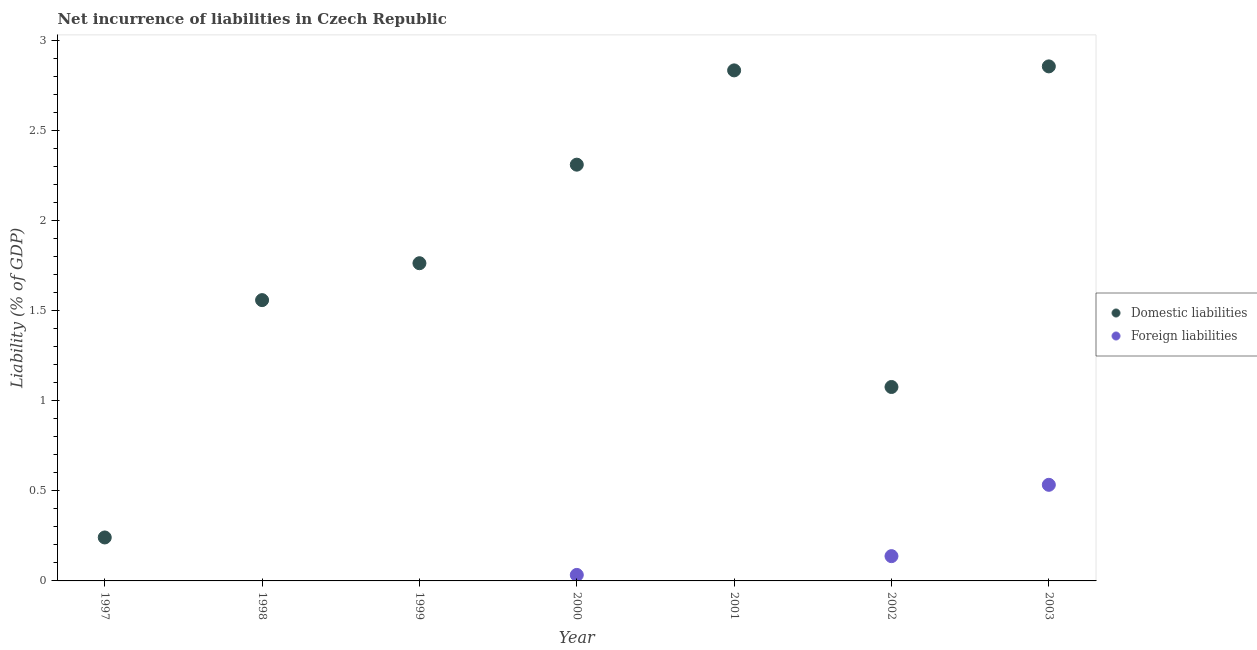Is the number of dotlines equal to the number of legend labels?
Offer a terse response. No. What is the incurrence of domestic liabilities in 1997?
Offer a terse response. 0.24. Across all years, what is the maximum incurrence of domestic liabilities?
Your answer should be compact. 2.86. In which year was the incurrence of foreign liabilities maximum?
Your answer should be compact. 2003. What is the total incurrence of domestic liabilities in the graph?
Ensure brevity in your answer.  12.65. What is the difference between the incurrence of foreign liabilities in 2002 and that in 2003?
Provide a short and direct response. -0.4. What is the difference between the incurrence of domestic liabilities in 2003 and the incurrence of foreign liabilities in 1999?
Keep it short and to the point. 2.86. What is the average incurrence of foreign liabilities per year?
Keep it short and to the point. 0.1. In the year 2002, what is the difference between the incurrence of foreign liabilities and incurrence of domestic liabilities?
Ensure brevity in your answer.  -0.94. In how many years, is the incurrence of domestic liabilities greater than 2.2 %?
Give a very brief answer. 3. What is the ratio of the incurrence of domestic liabilities in 1999 to that in 2000?
Your answer should be very brief. 0.76. Is the incurrence of domestic liabilities in 1998 less than that in 2003?
Your answer should be very brief. Yes. Is the difference between the incurrence of domestic liabilities in 2000 and 2002 greater than the difference between the incurrence of foreign liabilities in 2000 and 2002?
Keep it short and to the point. Yes. What is the difference between the highest and the second highest incurrence of foreign liabilities?
Offer a very short reply. 0.4. What is the difference between the highest and the lowest incurrence of foreign liabilities?
Give a very brief answer. 0.53. In how many years, is the incurrence of domestic liabilities greater than the average incurrence of domestic liabilities taken over all years?
Make the answer very short. 3. Is the incurrence of foreign liabilities strictly less than the incurrence of domestic liabilities over the years?
Make the answer very short. Yes. How many dotlines are there?
Give a very brief answer. 2. How many years are there in the graph?
Give a very brief answer. 7. What is the difference between two consecutive major ticks on the Y-axis?
Keep it short and to the point. 0.5. Does the graph contain any zero values?
Provide a succinct answer. Yes. Does the graph contain grids?
Ensure brevity in your answer.  No. How many legend labels are there?
Keep it short and to the point. 2. What is the title of the graph?
Make the answer very short. Net incurrence of liabilities in Czech Republic. Does "Arms imports" appear as one of the legend labels in the graph?
Make the answer very short. No. What is the label or title of the Y-axis?
Offer a very short reply. Liability (% of GDP). What is the Liability (% of GDP) of Domestic liabilities in 1997?
Offer a terse response. 0.24. What is the Liability (% of GDP) of Domestic liabilities in 1998?
Offer a terse response. 1.56. What is the Liability (% of GDP) of Domestic liabilities in 1999?
Offer a very short reply. 1.76. What is the Liability (% of GDP) of Domestic liabilities in 2000?
Provide a succinct answer. 2.31. What is the Liability (% of GDP) of Foreign liabilities in 2000?
Offer a very short reply. 0.03. What is the Liability (% of GDP) of Domestic liabilities in 2001?
Your answer should be very brief. 2.84. What is the Liability (% of GDP) in Domestic liabilities in 2002?
Offer a very short reply. 1.08. What is the Liability (% of GDP) of Foreign liabilities in 2002?
Your answer should be compact. 0.14. What is the Liability (% of GDP) in Domestic liabilities in 2003?
Make the answer very short. 2.86. What is the Liability (% of GDP) in Foreign liabilities in 2003?
Provide a short and direct response. 0.53. Across all years, what is the maximum Liability (% of GDP) in Domestic liabilities?
Make the answer very short. 2.86. Across all years, what is the maximum Liability (% of GDP) of Foreign liabilities?
Offer a very short reply. 0.53. Across all years, what is the minimum Liability (% of GDP) in Domestic liabilities?
Provide a short and direct response. 0.24. Across all years, what is the minimum Liability (% of GDP) in Foreign liabilities?
Ensure brevity in your answer.  0. What is the total Liability (% of GDP) in Domestic liabilities in the graph?
Keep it short and to the point. 12.65. What is the total Liability (% of GDP) of Foreign liabilities in the graph?
Ensure brevity in your answer.  0.7. What is the difference between the Liability (% of GDP) of Domestic liabilities in 1997 and that in 1998?
Offer a terse response. -1.32. What is the difference between the Liability (% of GDP) of Domestic liabilities in 1997 and that in 1999?
Keep it short and to the point. -1.52. What is the difference between the Liability (% of GDP) of Domestic liabilities in 1997 and that in 2000?
Your response must be concise. -2.07. What is the difference between the Liability (% of GDP) in Domestic liabilities in 1997 and that in 2001?
Keep it short and to the point. -2.59. What is the difference between the Liability (% of GDP) of Domestic liabilities in 1997 and that in 2002?
Offer a terse response. -0.84. What is the difference between the Liability (% of GDP) of Domestic liabilities in 1997 and that in 2003?
Provide a short and direct response. -2.62. What is the difference between the Liability (% of GDP) of Domestic liabilities in 1998 and that in 1999?
Keep it short and to the point. -0.2. What is the difference between the Liability (% of GDP) of Domestic liabilities in 1998 and that in 2000?
Your answer should be compact. -0.75. What is the difference between the Liability (% of GDP) of Domestic liabilities in 1998 and that in 2001?
Make the answer very short. -1.28. What is the difference between the Liability (% of GDP) of Domestic liabilities in 1998 and that in 2002?
Provide a short and direct response. 0.48. What is the difference between the Liability (% of GDP) in Domestic liabilities in 1998 and that in 2003?
Your answer should be compact. -1.3. What is the difference between the Liability (% of GDP) of Domestic liabilities in 1999 and that in 2000?
Ensure brevity in your answer.  -0.55. What is the difference between the Liability (% of GDP) of Domestic liabilities in 1999 and that in 2001?
Your answer should be compact. -1.07. What is the difference between the Liability (% of GDP) of Domestic liabilities in 1999 and that in 2002?
Offer a very short reply. 0.69. What is the difference between the Liability (% of GDP) in Domestic liabilities in 1999 and that in 2003?
Your answer should be very brief. -1.09. What is the difference between the Liability (% of GDP) in Domestic liabilities in 2000 and that in 2001?
Provide a short and direct response. -0.52. What is the difference between the Liability (% of GDP) of Domestic liabilities in 2000 and that in 2002?
Ensure brevity in your answer.  1.24. What is the difference between the Liability (% of GDP) of Foreign liabilities in 2000 and that in 2002?
Your answer should be very brief. -0.1. What is the difference between the Liability (% of GDP) of Domestic liabilities in 2000 and that in 2003?
Make the answer very short. -0.55. What is the difference between the Liability (% of GDP) in Foreign liabilities in 2000 and that in 2003?
Your answer should be compact. -0.5. What is the difference between the Liability (% of GDP) of Domestic liabilities in 2001 and that in 2002?
Give a very brief answer. 1.76. What is the difference between the Liability (% of GDP) of Domestic liabilities in 2001 and that in 2003?
Provide a short and direct response. -0.02. What is the difference between the Liability (% of GDP) in Domestic liabilities in 2002 and that in 2003?
Provide a succinct answer. -1.78. What is the difference between the Liability (% of GDP) of Foreign liabilities in 2002 and that in 2003?
Your answer should be very brief. -0.4. What is the difference between the Liability (% of GDP) of Domestic liabilities in 1997 and the Liability (% of GDP) of Foreign liabilities in 2000?
Keep it short and to the point. 0.21. What is the difference between the Liability (% of GDP) in Domestic liabilities in 1997 and the Liability (% of GDP) in Foreign liabilities in 2002?
Your response must be concise. 0.1. What is the difference between the Liability (% of GDP) in Domestic liabilities in 1997 and the Liability (% of GDP) in Foreign liabilities in 2003?
Make the answer very short. -0.29. What is the difference between the Liability (% of GDP) in Domestic liabilities in 1998 and the Liability (% of GDP) in Foreign liabilities in 2000?
Provide a short and direct response. 1.53. What is the difference between the Liability (% of GDP) in Domestic liabilities in 1998 and the Liability (% of GDP) in Foreign liabilities in 2002?
Provide a short and direct response. 1.42. What is the difference between the Liability (% of GDP) in Domestic liabilities in 1998 and the Liability (% of GDP) in Foreign liabilities in 2003?
Provide a succinct answer. 1.03. What is the difference between the Liability (% of GDP) of Domestic liabilities in 1999 and the Liability (% of GDP) of Foreign liabilities in 2000?
Offer a very short reply. 1.73. What is the difference between the Liability (% of GDP) in Domestic liabilities in 1999 and the Liability (% of GDP) in Foreign liabilities in 2002?
Provide a short and direct response. 1.63. What is the difference between the Liability (% of GDP) in Domestic liabilities in 1999 and the Liability (% of GDP) in Foreign liabilities in 2003?
Give a very brief answer. 1.23. What is the difference between the Liability (% of GDP) in Domestic liabilities in 2000 and the Liability (% of GDP) in Foreign liabilities in 2002?
Offer a terse response. 2.17. What is the difference between the Liability (% of GDP) of Domestic liabilities in 2000 and the Liability (% of GDP) of Foreign liabilities in 2003?
Ensure brevity in your answer.  1.78. What is the difference between the Liability (% of GDP) of Domestic liabilities in 2001 and the Liability (% of GDP) of Foreign liabilities in 2002?
Provide a succinct answer. 2.7. What is the difference between the Liability (% of GDP) of Domestic liabilities in 2001 and the Liability (% of GDP) of Foreign liabilities in 2003?
Make the answer very short. 2.3. What is the difference between the Liability (% of GDP) of Domestic liabilities in 2002 and the Liability (% of GDP) of Foreign liabilities in 2003?
Offer a very short reply. 0.54. What is the average Liability (% of GDP) of Domestic liabilities per year?
Offer a very short reply. 1.81. What is the average Liability (% of GDP) of Foreign liabilities per year?
Your answer should be very brief. 0.1. In the year 2000, what is the difference between the Liability (% of GDP) of Domestic liabilities and Liability (% of GDP) of Foreign liabilities?
Make the answer very short. 2.28. In the year 2002, what is the difference between the Liability (% of GDP) of Domestic liabilities and Liability (% of GDP) of Foreign liabilities?
Provide a short and direct response. 0.94. In the year 2003, what is the difference between the Liability (% of GDP) of Domestic liabilities and Liability (% of GDP) of Foreign liabilities?
Provide a short and direct response. 2.32. What is the ratio of the Liability (% of GDP) of Domestic liabilities in 1997 to that in 1998?
Make the answer very short. 0.15. What is the ratio of the Liability (% of GDP) of Domestic liabilities in 1997 to that in 1999?
Provide a short and direct response. 0.14. What is the ratio of the Liability (% of GDP) of Domestic liabilities in 1997 to that in 2000?
Your response must be concise. 0.1. What is the ratio of the Liability (% of GDP) of Domestic liabilities in 1997 to that in 2001?
Give a very brief answer. 0.09. What is the ratio of the Liability (% of GDP) of Domestic liabilities in 1997 to that in 2002?
Keep it short and to the point. 0.22. What is the ratio of the Liability (% of GDP) of Domestic liabilities in 1997 to that in 2003?
Your answer should be compact. 0.08. What is the ratio of the Liability (% of GDP) in Domestic liabilities in 1998 to that in 1999?
Your answer should be compact. 0.88. What is the ratio of the Liability (% of GDP) of Domestic liabilities in 1998 to that in 2000?
Make the answer very short. 0.67. What is the ratio of the Liability (% of GDP) of Domestic liabilities in 1998 to that in 2001?
Your answer should be compact. 0.55. What is the ratio of the Liability (% of GDP) of Domestic liabilities in 1998 to that in 2002?
Ensure brevity in your answer.  1.45. What is the ratio of the Liability (% of GDP) of Domestic liabilities in 1998 to that in 2003?
Provide a succinct answer. 0.55. What is the ratio of the Liability (% of GDP) of Domestic liabilities in 1999 to that in 2000?
Offer a very short reply. 0.76. What is the ratio of the Liability (% of GDP) in Domestic liabilities in 1999 to that in 2001?
Give a very brief answer. 0.62. What is the ratio of the Liability (% of GDP) of Domestic liabilities in 1999 to that in 2002?
Give a very brief answer. 1.64. What is the ratio of the Liability (% of GDP) in Domestic liabilities in 1999 to that in 2003?
Offer a terse response. 0.62. What is the ratio of the Liability (% of GDP) in Domestic liabilities in 2000 to that in 2001?
Provide a short and direct response. 0.82. What is the ratio of the Liability (% of GDP) of Domestic liabilities in 2000 to that in 2002?
Your response must be concise. 2.15. What is the ratio of the Liability (% of GDP) of Foreign liabilities in 2000 to that in 2002?
Ensure brevity in your answer.  0.24. What is the ratio of the Liability (% of GDP) in Domestic liabilities in 2000 to that in 2003?
Keep it short and to the point. 0.81. What is the ratio of the Liability (% of GDP) of Foreign liabilities in 2000 to that in 2003?
Offer a terse response. 0.06. What is the ratio of the Liability (% of GDP) of Domestic liabilities in 2001 to that in 2002?
Offer a terse response. 2.63. What is the ratio of the Liability (% of GDP) of Domestic liabilities in 2001 to that in 2003?
Make the answer very short. 0.99. What is the ratio of the Liability (% of GDP) in Domestic liabilities in 2002 to that in 2003?
Give a very brief answer. 0.38. What is the ratio of the Liability (% of GDP) of Foreign liabilities in 2002 to that in 2003?
Offer a terse response. 0.26. What is the difference between the highest and the second highest Liability (% of GDP) in Domestic liabilities?
Ensure brevity in your answer.  0.02. What is the difference between the highest and the second highest Liability (% of GDP) in Foreign liabilities?
Make the answer very short. 0.4. What is the difference between the highest and the lowest Liability (% of GDP) in Domestic liabilities?
Your response must be concise. 2.62. What is the difference between the highest and the lowest Liability (% of GDP) in Foreign liabilities?
Your answer should be compact. 0.53. 